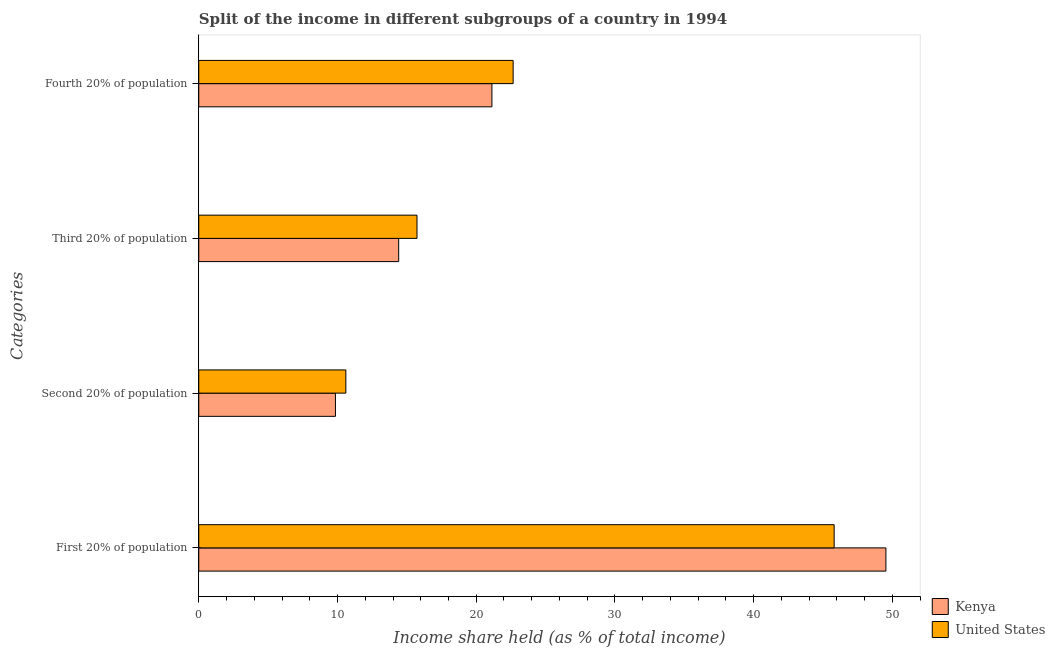How many different coloured bars are there?
Provide a succinct answer. 2. How many groups of bars are there?
Offer a very short reply. 4. Are the number of bars on each tick of the Y-axis equal?
Your answer should be very brief. Yes. How many bars are there on the 3rd tick from the top?
Your answer should be compact. 2. What is the label of the 1st group of bars from the top?
Provide a succinct answer. Fourth 20% of population. What is the share of the income held by second 20% of the population in United States?
Your answer should be very brief. 10.6. Across all countries, what is the maximum share of the income held by second 20% of the population?
Your answer should be compact. 10.6. Across all countries, what is the minimum share of the income held by third 20% of the population?
Provide a short and direct response. 14.41. What is the total share of the income held by second 20% of the population in the graph?
Your answer should be very brief. 20.45. What is the difference between the share of the income held by first 20% of the population in Kenya and that in United States?
Give a very brief answer. 3.73. What is the difference between the share of the income held by first 20% of the population in United States and the share of the income held by second 20% of the population in Kenya?
Offer a very short reply. 35.95. What is the average share of the income held by second 20% of the population per country?
Your answer should be very brief. 10.22. What is the difference between the share of the income held by second 20% of the population and share of the income held by third 20% of the population in United States?
Ensure brevity in your answer.  -5.13. What is the ratio of the share of the income held by third 20% of the population in United States to that in Kenya?
Offer a very short reply. 1.09. Is the difference between the share of the income held by first 20% of the population in United States and Kenya greater than the difference between the share of the income held by third 20% of the population in United States and Kenya?
Offer a very short reply. No. What is the difference between the highest and the second highest share of the income held by third 20% of the population?
Keep it short and to the point. 1.32. What is the difference between the highest and the lowest share of the income held by third 20% of the population?
Offer a terse response. 1.32. In how many countries, is the share of the income held by first 20% of the population greater than the average share of the income held by first 20% of the population taken over all countries?
Your response must be concise. 1. Is the sum of the share of the income held by third 20% of the population in United States and Kenya greater than the maximum share of the income held by first 20% of the population across all countries?
Your response must be concise. No. Is it the case that in every country, the sum of the share of the income held by second 20% of the population and share of the income held by first 20% of the population is greater than the sum of share of the income held by fourth 20% of the population and share of the income held by third 20% of the population?
Provide a succinct answer. Yes. What does the 2nd bar from the top in Second 20% of population represents?
Ensure brevity in your answer.  Kenya. Is it the case that in every country, the sum of the share of the income held by first 20% of the population and share of the income held by second 20% of the population is greater than the share of the income held by third 20% of the population?
Your response must be concise. Yes. How many bars are there?
Your answer should be compact. 8. Are all the bars in the graph horizontal?
Your answer should be compact. Yes. How many countries are there in the graph?
Ensure brevity in your answer.  2. What is the difference between two consecutive major ticks on the X-axis?
Ensure brevity in your answer.  10. Are the values on the major ticks of X-axis written in scientific E-notation?
Your response must be concise. No. Does the graph contain grids?
Your answer should be compact. No. Where does the legend appear in the graph?
Ensure brevity in your answer.  Bottom right. How are the legend labels stacked?
Offer a terse response. Vertical. What is the title of the graph?
Ensure brevity in your answer.  Split of the income in different subgroups of a country in 1994. What is the label or title of the X-axis?
Provide a succinct answer. Income share held (as % of total income). What is the label or title of the Y-axis?
Give a very brief answer. Categories. What is the Income share held (as % of total income) of Kenya in First 20% of population?
Offer a terse response. 49.53. What is the Income share held (as % of total income) in United States in First 20% of population?
Give a very brief answer. 45.8. What is the Income share held (as % of total income) in Kenya in Second 20% of population?
Your response must be concise. 9.85. What is the Income share held (as % of total income) in Kenya in Third 20% of population?
Make the answer very short. 14.41. What is the Income share held (as % of total income) of United States in Third 20% of population?
Ensure brevity in your answer.  15.73. What is the Income share held (as % of total income) of Kenya in Fourth 20% of population?
Provide a succinct answer. 21.13. What is the Income share held (as % of total income) of United States in Fourth 20% of population?
Provide a succinct answer. 22.66. Across all Categories, what is the maximum Income share held (as % of total income) in Kenya?
Your answer should be very brief. 49.53. Across all Categories, what is the maximum Income share held (as % of total income) of United States?
Provide a short and direct response. 45.8. Across all Categories, what is the minimum Income share held (as % of total income) of Kenya?
Offer a very short reply. 9.85. Across all Categories, what is the minimum Income share held (as % of total income) in United States?
Make the answer very short. 10.6. What is the total Income share held (as % of total income) of Kenya in the graph?
Ensure brevity in your answer.  94.92. What is the total Income share held (as % of total income) in United States in the graph?
Offer a terse response. 94.79. What is the difference between the Income share held (as % of total income) of Kenya in First 20% of population and that in Second 20% of population?
Make the answer very short. 39.68. What is the difference between the Income share held (as % of total income) in United States in First 20% of population and that in Second 20% of population?
Provide a succinct answer. 35.2. What is the difference between the Income share held (as % of total income) in Kenya in First 20% of population and that in Third 20% of population?
Your answer should be compact. 35.12. What is the difference between the Income share held (as % of total income) of United States in First 20% of population and that in Third 20% of population?
Ensure brevity in your answer.  30.07. What is the difference between the Income share held (as % of total income) of Kenya in First 20% of population and that in Fourth 20% of population?
Give a very brief answer. 28.4. What is the difference between the Income share held (as % of total income) of United States in First 20% of population and that in Fourth 20% of population?
Give a very brief answer. 23.14. What is the difference between the Income share held (as % of total income) of Kenya in Second 20% of population and that in Third 20% of population?
Your answer should be very brief. -4.56. What is the difference between the Income share held (as % of total income) in United States in Second 20% of population and that in Third 20% of population?
Provide a short and direct response. -5.13. What is the difference between the Income share held (as % of total income) of Kenya in Second 20% of population and that in Fourth 20% of population?
Keep it short and to the point. -11.28. What is the difference between the Income share held (as % of total income) in United States in Second 20% of population and that in Fourth 20% of population?
Your answer should be very brief. -12.06. What is the difference between the Income share held (as % of total income) in Kenya in Third 20% of population and that in Fourth 20% of population?
Make the answer very short. -6.72. What is the difference between the Income share held (as % of total income) of United States in Third 20% of population and that in Fourth 20% of population?
Your response must be concise. -6.93. What is the difference between the Income share held (as % of total income) in Kenya in First 20% of population and the Income share held (as % of total income) in United States in Second 20% of population?
Your answer should be very brief. 38.93. What is the difference between the Income share held (as % of total income) in Kenya in First 20% of population and the Income share held (as % of total income) in United States in Third 20% of population?
Give a very brief answer. 33.8. What is the difference between the Income share held (as % of total income) in Kenya in First 20% of population and the Income share held (as % of total income) in United States in Fourth 20% of population?
Make the answer very short. 26.87. What is the difference between the Income share held (as % of total income) of Kenya in Second 20% of population and the Income share held (as % of total income) of United States in Third 20% of population?
Offer a terse response. -5.88. What is the difference between the Income share held (as % of total income) in Kenya in Second 20% of population and the Income share held (as % of total income) in United States in Fourth 20% of population?
Offer a very short reply. -12.81. What is the difference between the Income share held (as % of total income) in Kenya in Third 20% of population and the Income share held (as % of total income) in United States in Fourth 20% of population?
Provide a short and direct response. -8.25. What is the average Income share held (as % of total income) of Kenya per Categories?
Provide a short and direct response. 23.73. What is the average Income share held (as % of total income) of United States per Categories?
Offer a very short reply. 23.7. What is the difference between the Income share held (as % of total income) in Kenya and Income share held (as % of total income) in United States in First 20% of population?
Offer a very short reply. 3.73. What is the difference between the Income share held (as % of total income) in Kenya and Income share held (as % of total income) in United States in Second 20% of population?
Provide a short and direct response. -0.75. What is the difference between the Income share held (as % of total income) of Kenya and Income share held (as % of total income) of United States in Third 20% of population?
Provide a succinct answer. -1.32. What is the difference between the Income share held (as % of total income) in Kenya and Income share held (as % of total income) in United States in Fourth 20% of population?
Ensure brevity in your answer.  -1.53. What is the ratio of the Income share held (as % of total income) in Kenya in First 20% of population to that in Second 20% of population?
Your answer should be compact. 5.03. What is the ratio of the Income share held (as % of total income) of United States in First 20% of population to that in Second 20% of population?
Offer a terse response. 4.32. What is the ratio of the Income share held (as % of total income) of Kenya in First 20% of population to that in Third 20% of population?
Your response must be concise. 3.44. What is the ratio of the Income share held (as % of total income) in United States in First 20% of population to that in Third 20% of population?
Make the answer very short. 2.91. What is the ratio of the Income share held (as % of total income) in Kenya in First 20% of population to that in Fourth 20% of population?
Provide a succinct answer. 2.34. What is the ratio of the Income share held (as % of total income) in United States in First 20% of population to that in Fourth 20% of population?
Provide a short and direct response. 2.02. What is the ratio of the Income share held (as % of total income) of Kenya in Second 20% of population to that in Third 20% of population?
Offer a very short reply. 0.68. What is the ratio of the Income share held (as % of total income) in United States in Second 20% of population to that in Third 20% of population?
Provide a succinct answer. 0.67. What is the ratio of the Income share held (as % of total income) of Kenya in Second 20% of population to that in Fourth 20% of population?
Provide a short and direct response. 0.47. What is the ratio of the Income share held (as % of total income) in United States in Second 20% of population to that in Fourth 20% of population?
Offer a very short reply. 0.47. What is the ratio of the Income share held (as % of total income) of Kenya in Third 20% of population to that in Fourth 20% of population?
Keep it short and to the point. 0.68. What is the ratio of the Income share held (as % of total income) in United States in Third 20% of population to that in Fourth 20% of population?
Your answer should be very brief. 0.69. What is the difference between the highest and the second highest Income share held (as % of total income) in Kenya?
Provide a short and direct response. 28.4. What is the difference between the highest and the second highest Income share held (as % of total income) of United States?
Your answer should be compact. 23.14. What is the difference between the highest and the lowest Income share held (as % of total income) in Kenya?
Provide a short and direct response. 39.68. What is the difference between the highest and the lowest Income share held (as % of total income) in United States?
Your response must be concise. 35.2. 